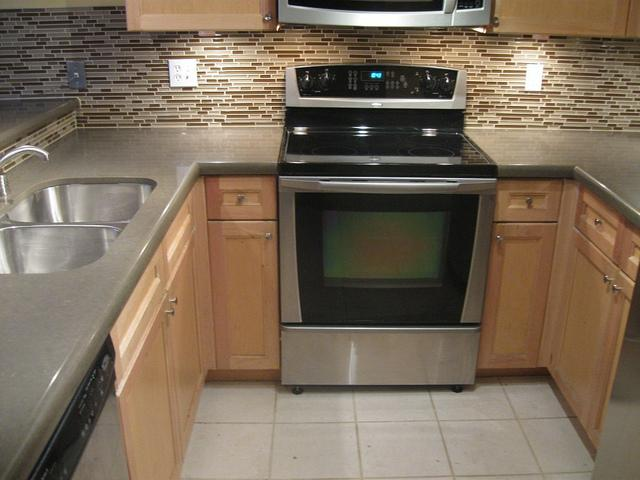What is the innermost color reflected off the center of the oven? Please explain your reasoning. red. The center of the reflection area is red. 